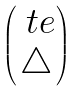<formula> <loc_0><loc_0><loc_500><loc_500>\begin{pmatrix} \ t e \\ \bigtriangleup \end{pmatrix}</formula> 